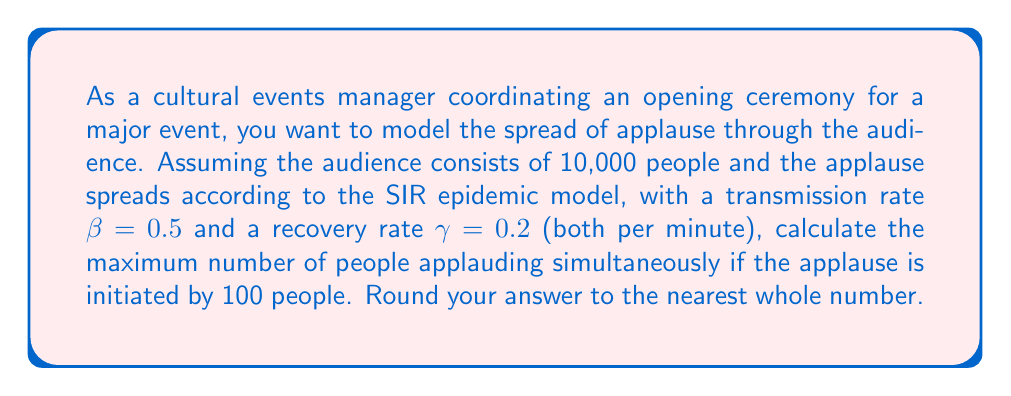Teach me how to tackle this problem. To solve this problem, we'll use the SIR (Susceptible-Infectious-Recovered) model, where in our case:
S = Susceptible (people not yet applauding)
I = Infectious (people currently applauding)
R = Recovered (people who have stopped applauding)

The key equations for the SIR model are:

$$\frac{dS}{dt} = -\beta SI$$
$$\frac{dI}{dt} = \beta SI - \gamma I$$
$$\frac{dR}{dt} = \gamma I$$

To find the maximum number of people applauding simultaneously, we need to find when $\frac{dI}{dt} = 0$:

$$\beta SI - \gamma I = 0$$
$$\beta S - \gamma = 0$$
$$S = \frac{\gamma}{\beta}$$

This occurs when the number of susceptible people equals $\frac{\gamma}{\beta}$.

Given:
- Total population: N = 10,000
- Initial infectious: $I_0 = 100$
- $\beta = 0.5$
- $\gamma = 0.2$

Calculate $\frac{\gamma}{\beta}$:
$$\frac{\gamma}{\beta} = \frac{0.2}{0.5} = 0.4$$

The number of susceptible people at the peak of applause is:
$$S_{peak} = 0.4 \times 10,000 = 4,000$$

To find the maximum number applauding, we use the conservation of population:
$$N = S + I + R$$
$$I_{max} = N - S_{peak} - R$$

At the start, R = 0, so:
$$I_{max} = 10,000 - 4,000 - 0 = 6,000$$

Therefore, the maximum number of people applauding simultaneously is 6,000.
Answer: 6,000 people 